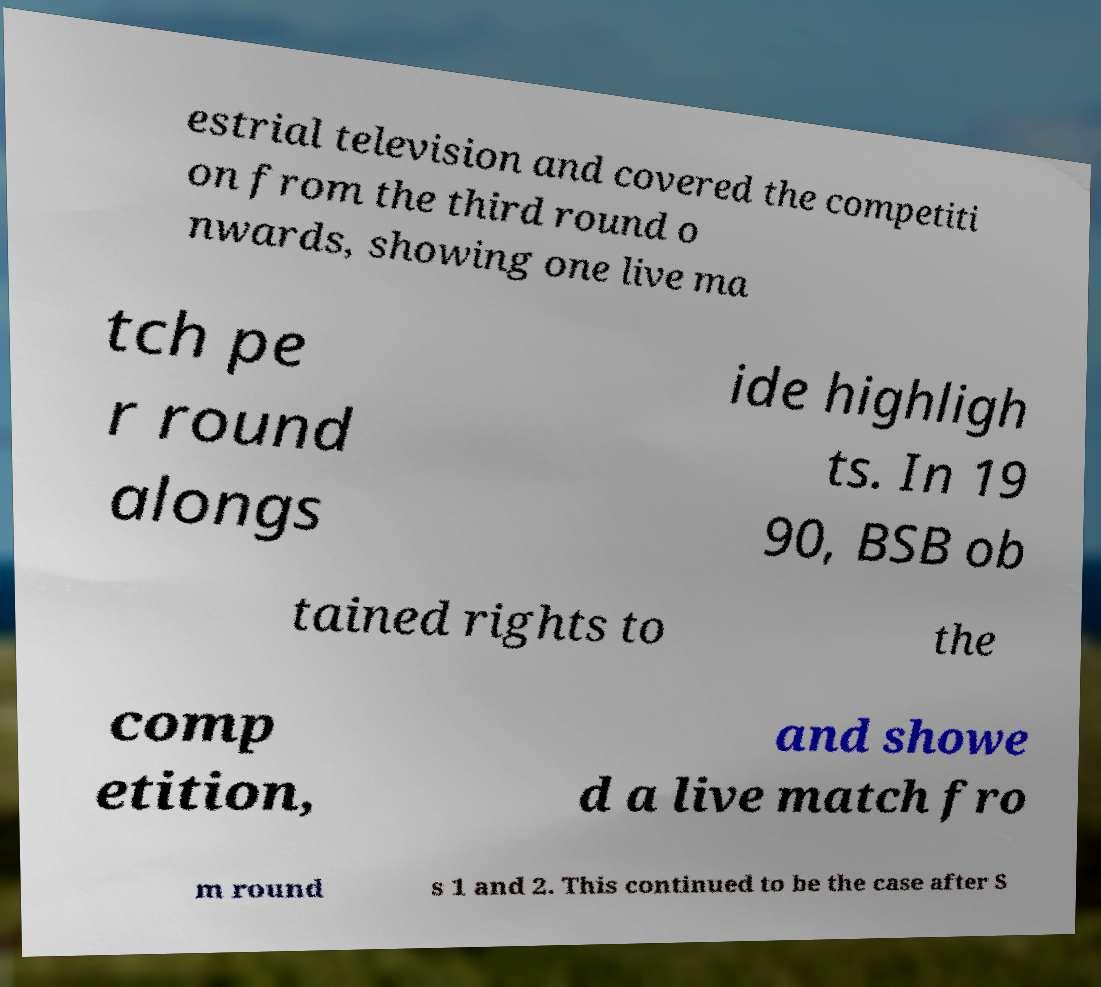Please identify and transcribe the text found in this image. estrial television and covered the competiti on from the third round o nwards, showing one live ma tch pe r round alongs ide highligh ts. In 19 90, BSB ob tained rights to the comp etition, and showe d a live match fro m round s 1 and 2. This continued to be the case after S 